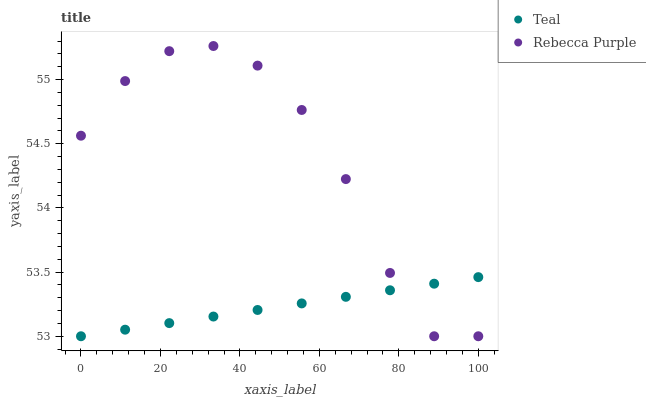Does Teal have the minimum area under the curve?
Answer yes or no. Yes. Does Rebecca Purple have the maximum area under the curve?
Answer yes or no. Yes. Does Teal have the maximum area under the curve?
Answer yes or no. No. Is Teal the smoothest?
Answer yes or no. Yes. Is Rebecca Purple the roughest?
Answer yes or no. Yes. Is Teal the roughest?
Answer yes or no. No. Does Rebecca Purple have the lowest value?
Answer yes or no. Yes. Does Rebecca Purple have the highest value?
Answer yes or no. Yes. Does Teal have the highest value?
Answer yes or no. No. Does Rebecca Purple intersect Teal?
Answer yes or no. Yes. Is Rebecca Purple less than Teal?
Answer yes or no. No. Is Rebecca Purple greater than Teal?
Answer yes or no. No. 